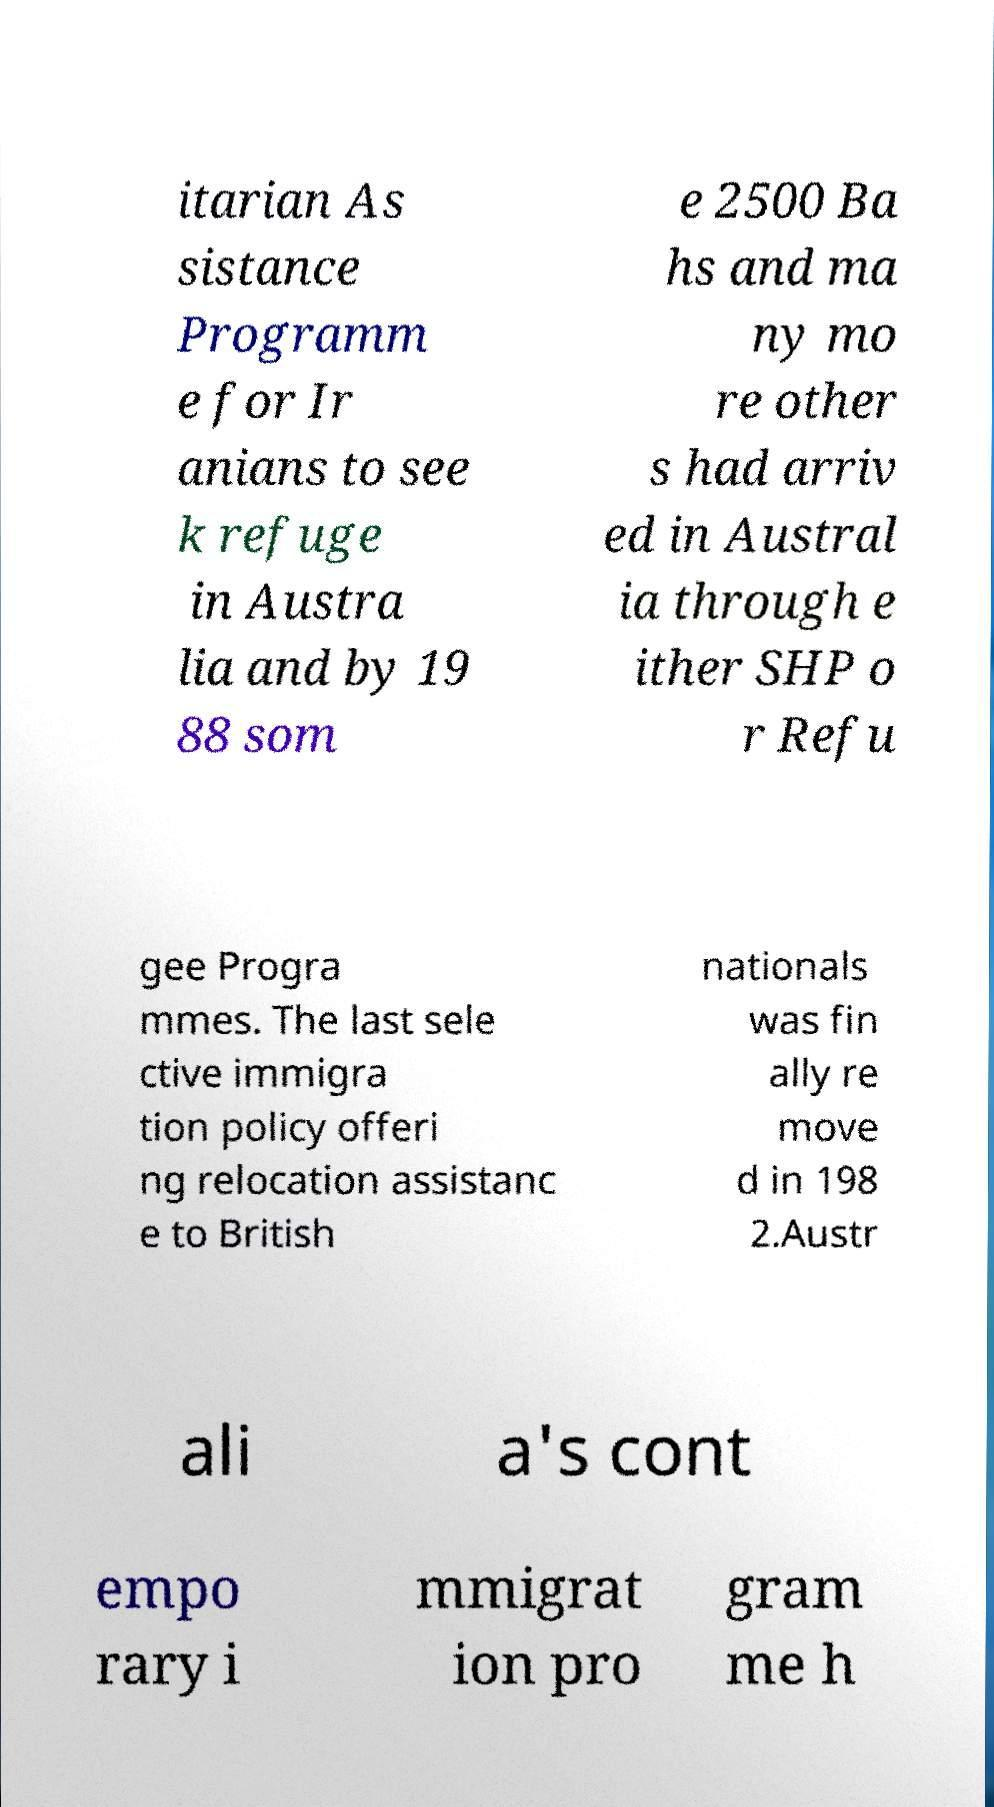Can you accurately transcribe the text from the provided image for me? itarian As sistance Programm e for Ir anians to see k refuge in Austra lia and by 19 88 som e 2500 Ba hs and ma ny mo re other s had arriv ed in Austral ia through e ither SHP o r Refu gee Progra mmes. The last sele ctive immigra tion policy offeri ng relocation assistanc e to British nationals was fin ally re move d in 198 2.Austr ali a's cont empo rary i mmigrat ion pro gram me h 